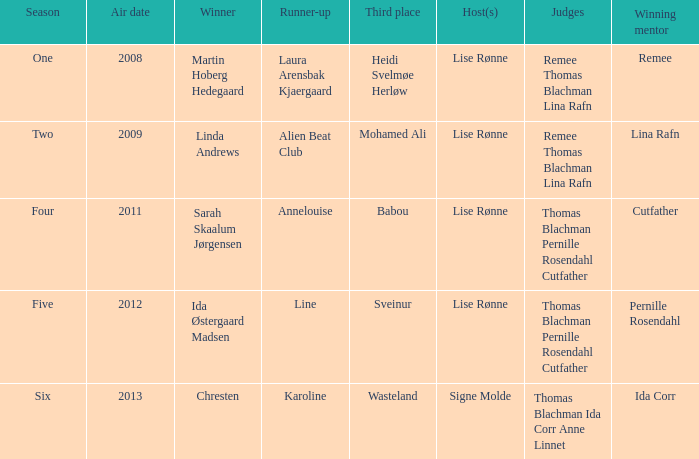Who was the runner-up in season five? Line. 